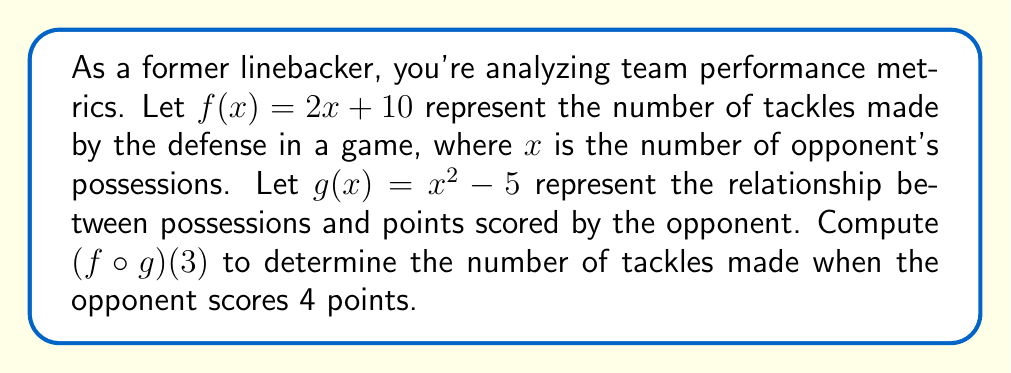Show me your answer to this math problem. To solve this problem, we need to follow these steps:

1) First, we need to understand what $(f \circ g)(x)$ means. It means we apply function $g$ first, then apply function $f$ to the result.

2) We're asked to find $(f \circ g)(3)$, so we start by calculating $g(3)$:

   $g(3) = 3^2 - 5 = 9 - 5 = 4$

3) Now we need to apply $f$ to this result:

   $f(g(3)) = f(4)$

4) We can now calculate $f(4)$:

   $f(4) = 2(4) + 10 = 8 + 10 = 18$

5) Therefore, $(f \circ g)(3) = 18$

6) Interpreting the result: When the opponent has 3 possessions, they score $g(3) = 4$ points, and the defense makes 18 tackles.
Answer: 18 tackles 